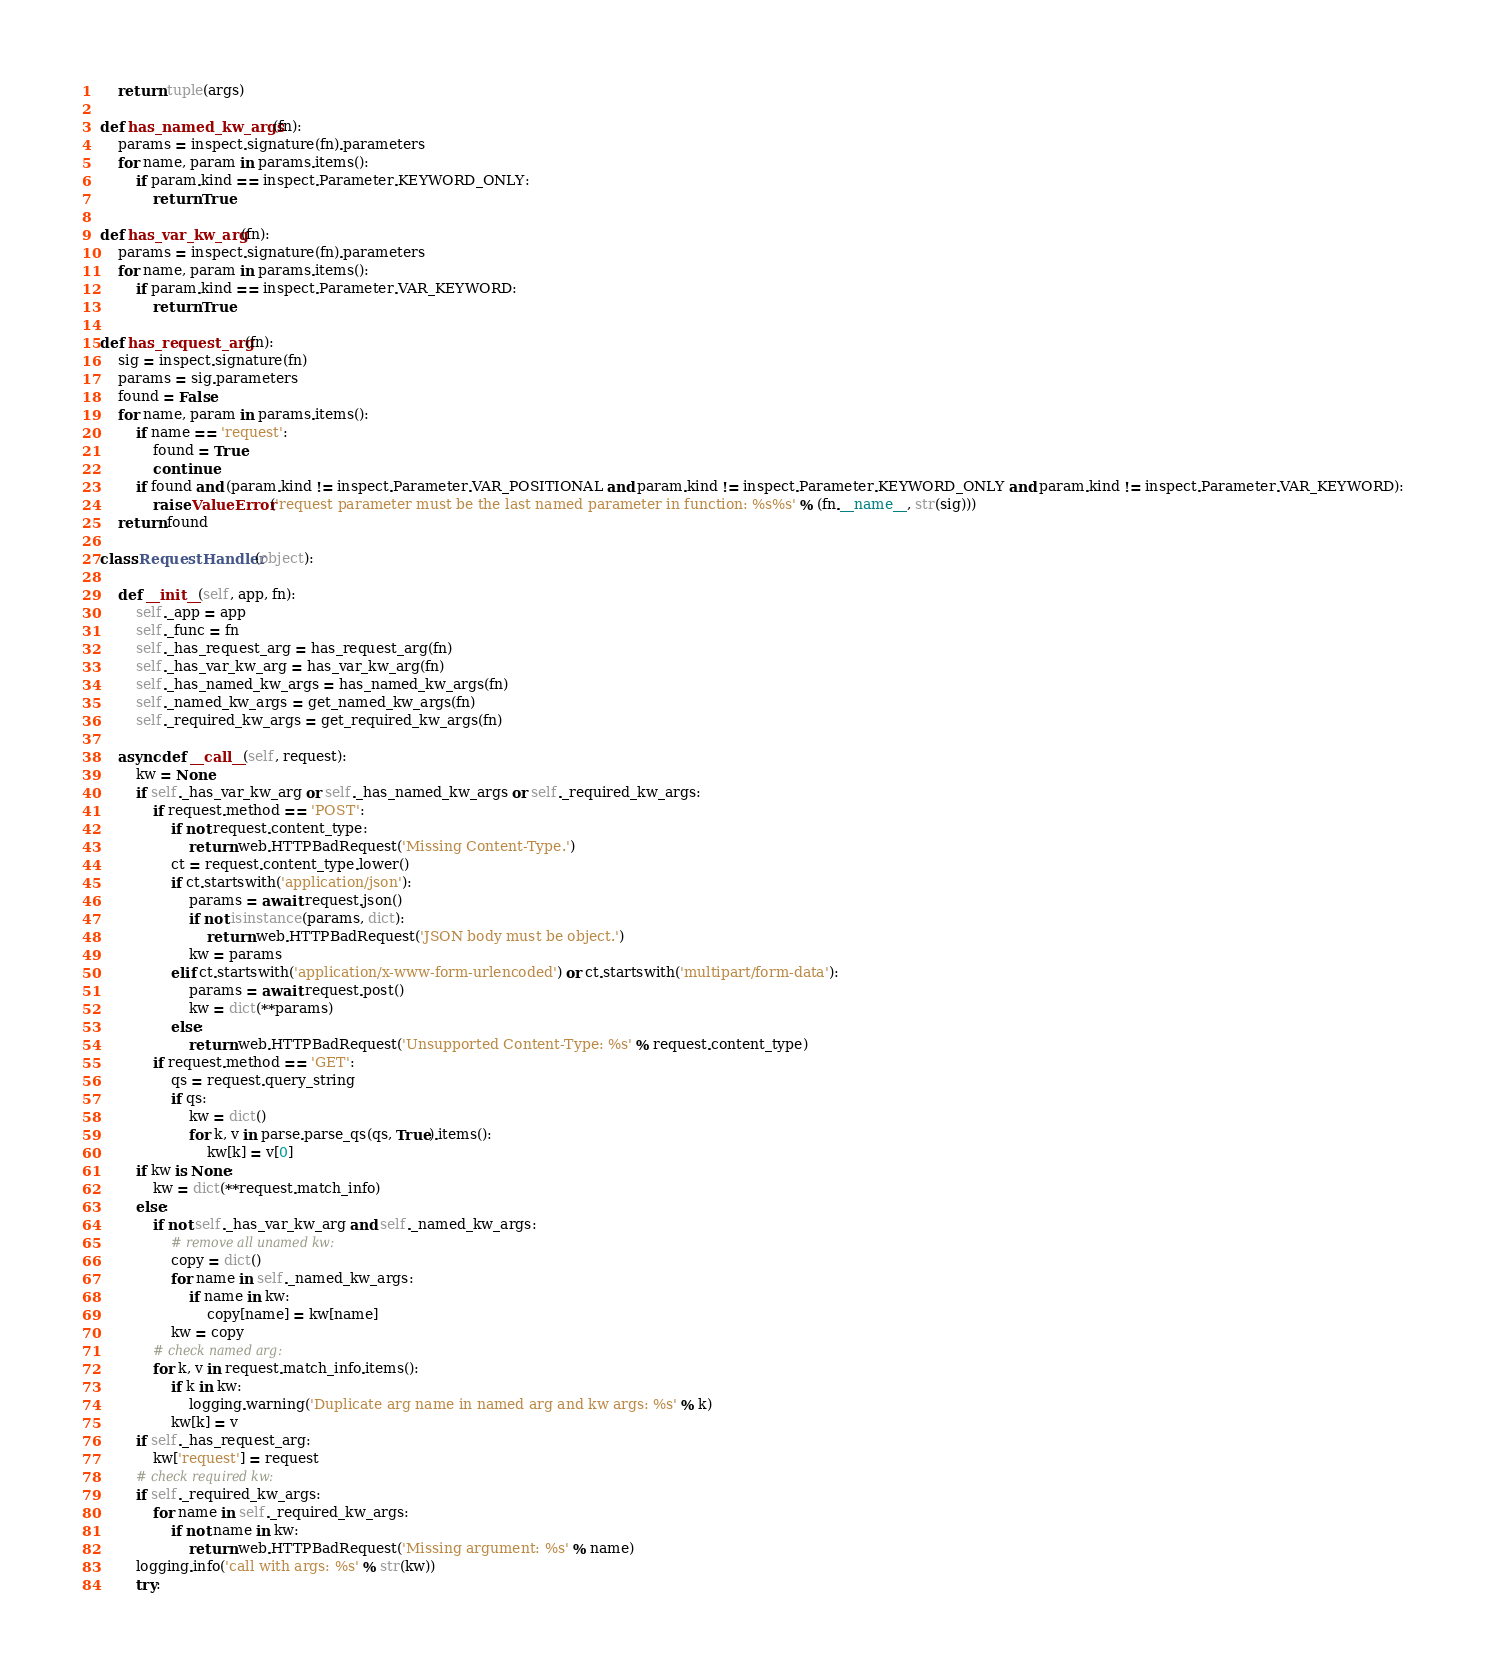<code> <loc_0><loc_0><loc_500><loc_500><_Python_>    return tuple(args)

def has_named_kw_args(fn):
    params = inspect.signature(fn).parameters
    for name, param in params.items():
        if param.kind == inspect.Parameter.KEYWORD_ONLY:
            return True

def has_var_kw_arg(fn):
    params = inspect.signature(fn).parameters
    for name, param in params.items():
        if param.kind == inspect.Parameter.VAR_KEYWORD:
            return True

def has_request_arg(fn):
    sig = inspect.signature(fn)
    params = sig.parameters
    found = False
    for name, param in params.items():
        if name == 'request':
            found = True
            continue
        if found and (param.kind != inspect.Parameter.VAR_POSITIONAL and param.kind != inspect.Parameter.KEYWORD_ONLY and param.kind != inspect.Parameter.VAR_KEYWORD):
            raise ValueError('request parameter must be the last named parameter in function: %s%s' % (fn.__name__, str(sig)))
    return found

class RequestHandler(object):

    def __init__(self, app, fn):
        self._app = app
        self._func = fn
        self._has_request_arg = has_request_arg(fn)
        self._has_var_kw_arg = has_var_kw_arg(fn)
        self._has_named_kw_args = has_named_kw_args(fn)
        self._named_kw_args = get_named_kw_args(fn)
        self._required_kw_args = get_required_kw_args(fn)

    async def __call__(self, request):
        kw = None
        if self._has_var_kw_arg or self._has_named_kw_args or self._required_kw_args:
            if request.method == 'POST':
                if not request.content_type:
                    return web.HTTPBadRequest('Missing Content-Type.')
                ct = request.content_type.lower()
                if ct.startswith('application/json'):
                    params = await request.json()
                    if not isinstance(params, dict):
                        return web.HTTPBadRequest('JSON body must be object.')
                    kw = params
                elif ct.startswith('application/x-www-form-urlencoded') or ct.startswith('multipart/form-data'):
                    params = await request.post()
                    kw = dict(**params)
                else:
                    return web.HTTPBadRequest('Unsupported Content-Type: %s' % request.content_type)
            if request.method == 'GET':
                qs = request.query_string
                if qs:
                    kw = dict()
                    for k, v in parse.parse_qs(qs, True).items():
                        kw[k] = v[0]
        if kw is None:
            kw = dict(**request.match_info)
        else:
            if not self._has_var_kw_arg and self._named_kw_args:
                # remove all unamed kw:
                copy = dict()
                for name in self._named_kw_args:
                    if name in kw:
                        copy[name] = kw[name]
                kw = copy
            # check named arg:
            for k, v in request.match_info.items():
                if k in kw:
                    logging.warning('Duplicate arg name in named arg and kw args: %s' % k)
                kw[k] = v
        if self._has_request_arg:
            kw['request'] = request
        # check required kw:
        if self._required_kw_args:
            for name in self._required_kw_args:
                if not name in kw:
                    return web.HTTPBadRequest('Missing argument: %s' % name)
        logging.info('call with args: %s' % str(kw))
        try:</code> 